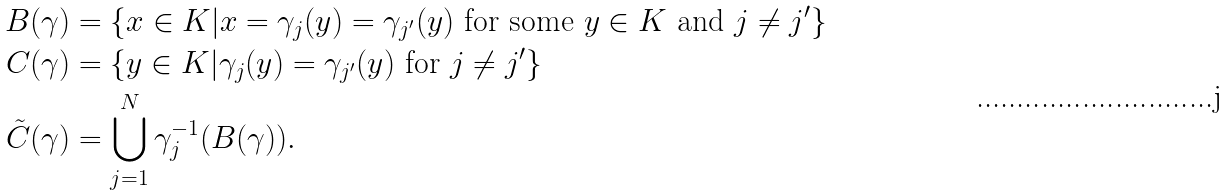Convert formula to latex. <formula><loc_0><loc_0><loc_500><loc_500>B ( \gamma ) & = \{ x \in K | x = \gamma _ { j } ( y ) = \gamma _ { j ^ { \prime } } ( y ) \text { for some } y \in K \text { and } j \ne j ^ { \prime } \} \\ C ( \gamma ) & = \{ y \in K | \gamma _ { j } ( y ) = \gamma _ { j ^ { \prime } } ( y ) \text { for } j \ne j ^ { \prime } \} \\ \tilde { C } ( \gamma ) & = \bigcup _ { j = 1 } ^ { N } \gamma _ { j } ^ { - 1 } ( B ( \gamma ) ) .</formula> 